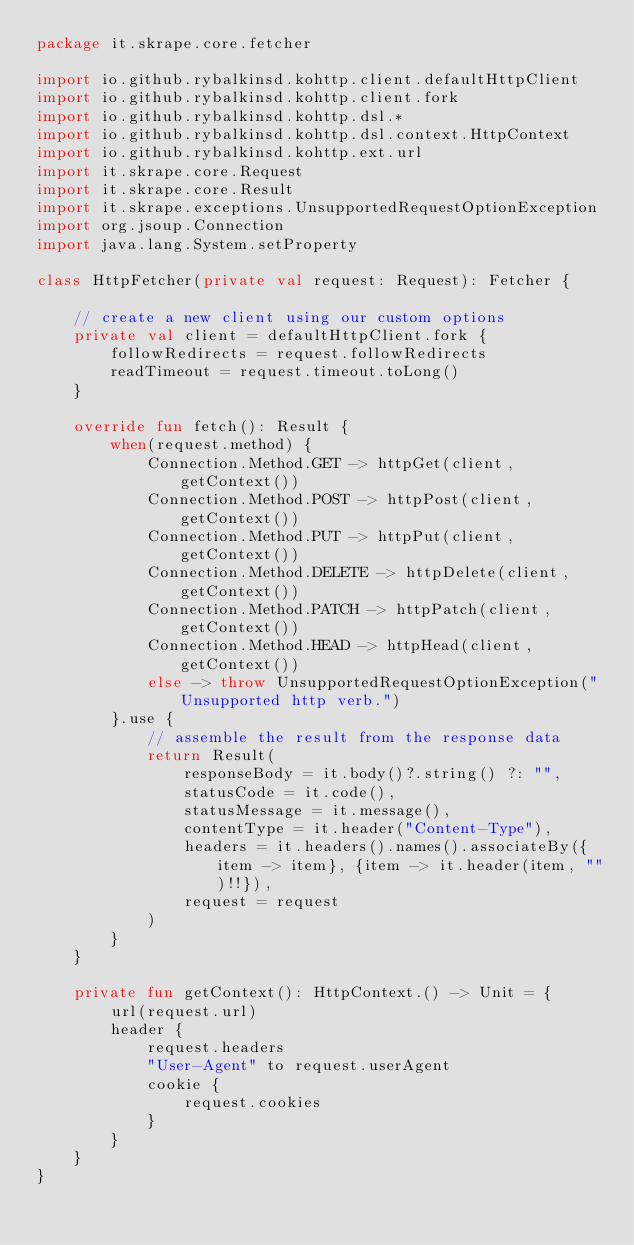<code> <loc_0><loc_0><loc_500><loc_500><_Kotlin_>package it.skrape.core.fetcher

import io.github.rybalkinsd.kohttp.client.defaultHttpClient
import io.github.rybalkinsd.kohttp.client.fork
import io.github.rybalkinsd.kohttp.dsl.*
import io.github.rybalkinsd.kohttp.dsl.context.HttpContext
import io.github.rybalkinsd.kohttp.ext.url
import it.skrape.core.Request
import it.skrape.core.Result
import it.skrape.exceptions.UnsupportedRequestOptionException
import org.jsoup.Connection
import java.lang.System.setProperty

class HttpFetcher(private val request: Request): Fetcher {

	// create a new client using our custom options
	private val client = defaultHttpClient.fork {
		followRedirects = request.followRedirects
		readTimeout = request.timeout.toLong()
	}

	override fun fetch(): Result {
		when(request.method) {
			Connection.Method.GET -> httpGet(client, getContext())
			Connection.Method.POST -> httpPost(client, getContext())
			Connection.Method.PUT -> httpPut(client, getContext())
			Connection.Method.DELETE -> httpDelete(client, getContext())
			Connection.Method.PATCH -> httpPatch(client, getContext())
			Connection.Method.HEAD -> httpHead(client, getContext())
			else -> throw UnsupportedRequestOptionException("Unsupported http verb.")
		}.use {
			// assemble the result from the response data
			return Result(
				responseBody = it.body()?.string() ?: "",
				statusCode = it.code(),
				statusMessage = it.message(),
				contentType = it.header("Content-Type"),
				headers = it.headers().names().associateBy({item -> item}, {item -> it.header(item, "")!!}),
				request = request
			)
		}
	}

	private fun getContext(): HttpContext.() -> Unit = {
		url(request.url)
		header {
			request.headers
			"User-Agent" to request.userAgent
			cookie {
				request.cookies
			}
		}
	}
}
</code> 